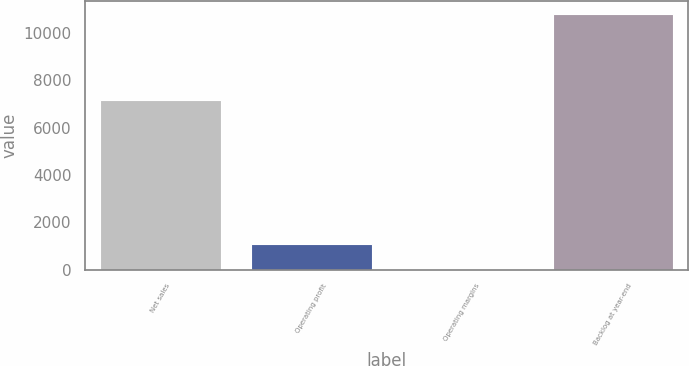<chart> <loc_0><loc_0><loc_500><loc_500><bar_chart><fcel>Net sales<fcel>Operating profit<fcel>Operating margins<fcel>Backlog at year-end<nl><fcel>7153<fcel>1091.43<fcel>12.7<fcel>10800<nl></chart> 